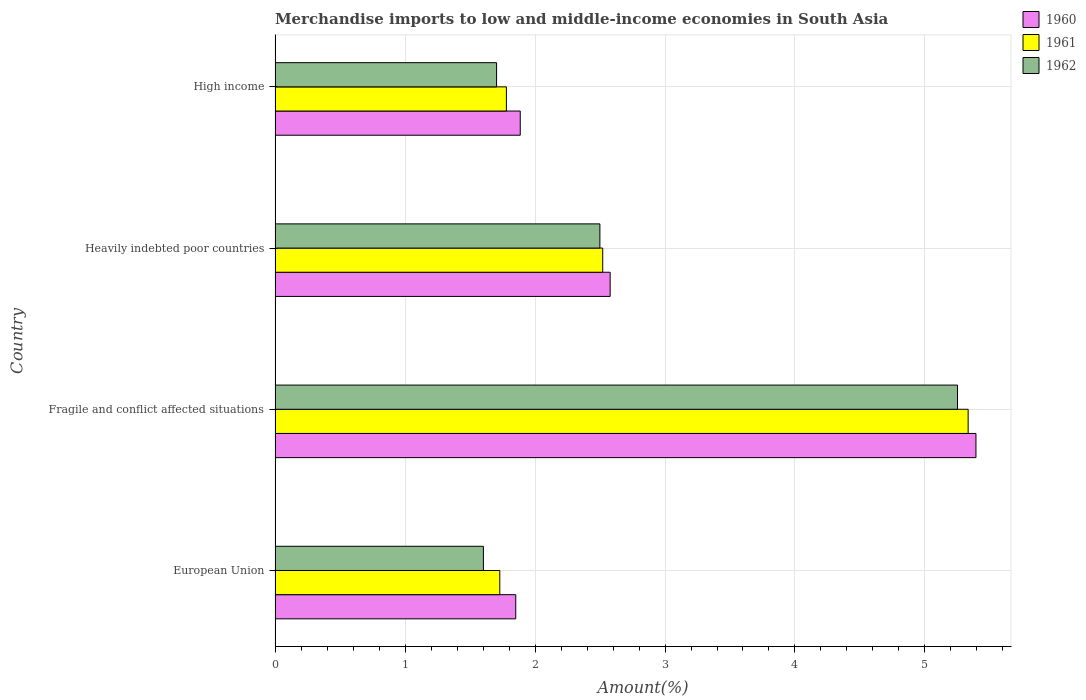How many groups of bars are there?
Offer a very short reply. 4. Are the number of bars per tick equal to the number of legend labels?
Make the answer very short. Yes. How many bars are there on the 3rd tick from the top?
Give a very brief answer. 3. How many bars are there on the 2nd tick from the bottom?
Your answer should be compact. 3. What is the label of the 4th group of bars from the top?
Make the answer very short. European Union. What is the percentage of amount earned from merchandise imports in 1961 in Fragile and conflict affected situations?
Offer a terse response. 5.33. Across all countries, what is the maximum percentage of amount earned from merchandise imports in 1961?
Provide a succinct answer. 5.33. Across all countries, what is the minimum percentage of amount earned from merchandise imports in 1962?
Ensure brevity in your answer.  1.6. In which country was the percentage of amount earned from merchandise imports in 1960 maximum?
Provide a short and direct response. Fragile and conflict affected situations. What is the total percentage of amount earned from merchandise imports in 1961 in the graph?
Your answer should be very brief. 11.36. What is the difference between the percentage of amount earned from merchandise imports in 1960 in Fragile and conflict affected situations and that in High income?
Your answer should be very brief. 3.51. What is the difference between the percentage of amount earned from merchandise imports in 1961 in High income and the percentage of amount earned from merchandise imports in 1962 in Fragile and conflict affected situations?
Your answer should be compact. -3.47. What is the average percentage of amount earned from merchandise imports in 1962 per country?
Provide a succinct answer. 2.76. What is the difference between the percentage of amount earned from merchandise imports in 1962 and percentage of amount earned from merchandise imports in 1961 in High income?
Offer a terse response. -0.08. In how many countries, is the percentage of amount earned from merchandise imports in 1961 greater than 1.2 %?
Your answer should be compact. 4. What is the ratio of the percentage of amount earned from merchandise imports in 1961 in European Union to that in Fragile and conflict affected situations?
Your response must be concise. 0.32. Is the percentage of amount earned from merchandise imports in 1960 in European Union less than that in Heavily indebted poor countries?
Offer a terse response. Yes. What is the difference between the highest and the second highest percentage of amount earned from merchandise imports in 1960?
Ensure brevity in your answer.  2.81. What is the difference between the highest and the lowest percentage of amount earned from merchandise imports in 1961?
Provide a short and direct response. 3.6. Is it the case that in every country, the sum of the percentage of amount earned from merchandise imports in 1960 and percentage of amount earned from merchandise imports in 1961 is greater than the percentage of amount earned from merchandise imports in 1962?
Ensure brevity in your answer.  Yes. How many bars are there?
Provide a succinct answer. 12. What is the difference between two consecutive major ticks on the X-axis?
Your response must be concise. 1. Are the values on the major ticks of X-axis written in scientific E-notation?
Keep it short and to the point. No. How many legend labels are there?
Ensure brevity in your answer.  3. How are the legend labels stacked?
Keep it short and to the point. Vertical. What is the title of the graph?
Keep it short and to the point. Merchandise imports to low and middle-income economies in South Asia. What is the label or title of the X-axis?
Provide a succinct answer. Amount(%). What is the label or title of the Y-axis?
Give a very brief answer. Country. What is the Amount(%) of 1960 in European Union?
Keep it short and to the point. 1.85. What is the Amount(%) of 1961 in European Union?
Your response must be concise. 1.73. What is the Amount(%) of 1962 in European Union?
Make the answer very short. 1.6. What is the Amount(%) of 1960 in Fragile and conflict affected situations?
Offer a terse response. 5.39. What is the Amount(%) of 1961 in Fragile and conflict affected situations?
Make the answer very short. 5.33. What is the Amount(%) of 1962 in Fragile and conflict affected situations?
Make the answer very short. 5.25. What is the Amount(%) in 1960 in Heavily indebted poor countries?
Your response must be concise. 2.58. What is the Amount(%) of 1961 in Heavily indebted poor countries?
Make the answer very short. 2.52. What is the Amount(%) of 1962 in Heavily indebted poor countries?
Keep it short and to the point. 2.5. What is the Amount(%) in 1960 in High income?
Your response must be concise. 1.89. What is the Amount(%) in 1961 in High income?
Ensure brevity in your answer.  1.78. What is the Amount(%) in 1962 in High income?
Keep it short and to the point. 1.7. Across all countries, what is the maximum Amount(%) of 1960?
Keep it short and to the point. 5.39. Across all countries, what is the maximum Amount(%) in 1961?
Your answer should be very brief. 5.33. Across all countries, what is the maximum Amount(%) in 1962?
Ensure brevity in your answer.  5.25. Across all countries, what is the minimum Amount(%) of 1960?
Offer a terse response. 1.85. Across all countries, what is the minimum Amount(%) of 1961?
Your response must be concise. 1.73. Across all countries, what is the minimum Amount(%) in 1962?
Your response must be concise. 1.6. What is the total Amount(%) in 1960 in the graph?
Provide a succinct answer. 11.71. What is the total Amount(%) in 1961 in the graph?
Provide a succinct answer. 11.36. What is the total Amount(%) of 1962 in the graph?
Offer a very short reply. 11.06. What is the difference between the Amount(%) in 1960 in European Union and that in Fragile and conflict affected situations?
Give a very brief answer. -3.54. What is the difference between the Amount(%) in 1961 in European Union and that in Fragile and conflict affected situations?
Keep it short and to the point. -3.6. What is the difference between the Amount(%) in 1962 in European Union and that in Fragile and conflict affected situations?
Your response must be concise. -3.65. What is the difference between the Amount(%) of 1960 in European Union and that in Heavily indebted poor countries?
Make the answer very short. -0.73. What is the difference between the Amount(%) of 1961 in European Union and that in Heavily indebted poor countries?
Keep it short and to the point. -0.79. What is the difference between the Amount(%) of 1962 in European Union and that in Heavily indebted poor countries?
Ensure brevity in your answer.  -0.9. What is the difference between the Amount(%) of 1960 in European Union and that in High income?
Provide a succinct answer. -0.03. What is the difference between the Amount(%) in 1961 in European Union and that in High income?
Keep it short and to the point. -0.05. What is the difference between the Amount(%) of 1962 in European Union and that in High income?
Your response must be concise. -0.1. What is the difference between the Amount(%) of 1960 in Fragile and conflict affected situations and that in Heavily indebted poor countries?
Make the answer very short. 2.81. What is the difference between the Amount(%) in 1961 in Fragile and conflict affected situations and that in Heavily indebted poor countries?
Keep it short and to the point. 2.81. What is the difference between the Amount(%) in 1962 in Fragile and conflict affected situations and that in Heavily indebted poor countries?
Provide a short and direct response. 2.75. What is the difference between the Amount(%) of 1960 in Fragile and conflict affected situations and that in High income?
Ensure brevity in your answer.  3.51. What is the difference between the Amount(%) of 1961 in Fragile and conflict affected situations and that in High income?
Provide a succinct answer. 3.55. What is the difference between the Amount(%) of 1962 in Fragile and conflict affected situations and that in High income?
Your answer should be compact. 3.55. What is the difference between the Amount(%) in 1960 in Heavily indebted poor countries and that in High income?
Keep it short and to the point. 0.69. What is the difference between the Amount(%) of 1961 in Heavily indebted poor countries and that in High income?
Make the answer very short. 0.74. What is the difference between the Amount(%) of 1962 in Heavily indebted poor countries and that in High income?
Offer a terse response. 0.79. What is the difference between the Amount(%) of 1960 in European Union and the Amount(%) of 1961 in Fragile and conflict affected situations?
Ensure brevity in your answer.  -3.48. What is the difference between the Amount(%) of 1960 in European Union and the Amount(%) of 1962 in Fragile and conflict affected situations?
Offer a very short reply. -3.4. What is the difference between the Amount(%) in 1961 in European Union and the Amount(%) in 1962 in Fragile and conflict affected situations?
Your answer should be very brief. -3.52. What is the difference between the Amount(%) in 1960 in European Union and the Amount(%) in 1961 in Heavily indebted poor countries?
Make the answer very short. -0.67. What is the difference between the Amount(%) of 1960 in European Union and the Amount(%) of 1962 in Heavily indebted poor countries?
Provide a succinct answer. -0.65. What is the difference between the Amount(%) of 1961 in European Union and the Amount(%) of 1962 in Heavily indebted poor countries?
Offer a terse response. -0.77. What is the difference between the Amount(%) in 1960 in European Union and the Amount(%) in 1961 in High income?
Provide a succinct answer. 0.07. What is the difference between the Amount(%) of 1960 in European Union and the Amount(%) of 1962 in High income?
Keep it short and to the point. 0.15. What is the difference between the Amount(%) in 1961 in European Union and the Amount(%) in 1962 in High income?
Provide a succinct answer. 0.02. What is the difference between the Amount(%) in 1960 in Fragile and conflict affected situations and the Amount(%) in 1961 in Heavily indebted poor countries?
Provide a succinct answer. 2.87. What is the difference between the Amount(%) of 1960 in Fragile and conflict affected situations and the Amount(%) of 1962 in Heavily indebted poor countries?
Ensure brevity in your answer.  2.89. What is the difference between the Amount(%) of 1961 in Fragile and conflict affected situations and the Amount(%) of 1962 in Heavily indebted poor countries?
Ensure brevity in your answer.  2.83. What is the difference between the Amount(%) in 1960 in Fragile and conflict affected situations and the Amount(%) in 1961 in High income?
Provide a short and direct response. 3.61. What is the difference between the Amount(%) in 1960 in Fragile and conflict affected situations and the Amount(%) in 1962 in High income?
Your answer should be compact. 3.69. What is the difference between the Amount(%) of 1961 in Fragile and conflict affected situations and the Amount(%) of 1962 in High income?
Provide a succinct answer. 3.63. What is the difference between the Amount(%) of 1960 in Heavily indebted poor countries and the Amount(%) of 1961 in High income?
Provide a succinct answer. 0.8. What is the difference between the Amount(%) in 1960 in Heavily indebted poor countries and the Amount(%) in 1962 in High income?
Offer a terse response. 0.87. What is the difference between the Amount(%) of 1961 in Heavily indebted poor countries and the Amount(%) of 1962 in High income?
Provide a short and direct response. 0.82. What is the average Amount(%) in 1960 per country?
Make the answer very short. 2.93. What is the average Amount(%) of 1961 per country?
Give a very brief answer. 2.84. What is the average Amount(%) in 1962 per country?
Offer a terse response. 2.76. What is the difference between the Amount(%) in 1960 and Amount(%) in 1961 in European Union?
Your response must be concise. 0.12. What is the difference between the Amount(%) of 1960 and Amount(%) of 1962 in European Union?
Give a very brief answer. 0.25. What is the difference between the Amount(%) of 1961 and Amount(%) of 1962 in European Union?
Give a very brief answer. 0.13. What is the difference between the Amount(%) in 1960 and Amount(%) in 1961 in Fragile and conflict affected situations?
Ensure brevity in your answer.  0.06. What is the difference between the Amount(%) in 1960 and Amount(%) in 1962 in Fragile and conflict affected situations?
Ensure brevity in your answer.  0.14. What is the difference between the Amount(%) in 1961 and Amount(%) in 1962 in Fragile and conflict affected situations?
Keep it short and to the point. 0.08. What is the difference between the Amount(%) in 1960 and Amount(%) in 1961 in Heavily indebted poor countries?
Provide a succinct answer. 0.06. What is the difference between the Amount(%) in 1960 and Amount(%) in 1962 in Heavily indebted poor countries?
Provide a succinct answer. 0.08. What is the difference between the Amount(%) of 1961 and Amount(%) of 1962 in Heavily indebted poor countries?
Your response must be concise. 0.02. What is the difference between the Amount(%) in 1960 and Amount(%) in 1961 in High income?
Your answer should be compact. 0.11. What is the difference between the Amount(%) in 1960 and Amount(%) in 1962 in High income?
Your answer should be compact. 0.18. What is the difference between the Amount(%) in 1961 and Amount(%) in 1962 in High income?
Make the answer very short. 0.08. What is the ratio of the Amount(%) in 1960 in European Union to that in Fragile and conflict affected situations?
Provide a succinct answer. 0.34. What is the ratio of the Amount(%) in 1961 in European Union to that in Fragile and conflict affected situations?
Offer a terse response. 0.32. What is the ratio of the Amount(%) of 1962 in European Union to that in Fragile and conflict affected situations?
Offer a terse response. 0.31. What is the ratio of the Amount(%) in 1960 in European Union to that in Heavily indebted poor countries?
Your answer should be very brief. 0.72. What is the ratio of the Amount(%) in 1961 in European Union to that in Heavily indebted poor countries?
Give a very brief answer. 0.69. What is the ratio of the Amount(%) of 1962 in European Union to that in Heavily indebted poor countries?
Ensure brevity in your answer.  0.64. What is the ratio of the Amount(%) of 1960 in European Union to that in High income?
Make the answer very short. 0.98. What is the ratio of the Amount(%) in 1961 in European Union to that in High income?
Give a very brief answer. 0.97. What is the ratio of the Amount(%) of 1962 in European Union to that in High income?
Your answer should be very brief. 0.94. What is the ratio of the Amount(%) in 1960 in Fragile and conflict affected situations to that in Heavily indebted poor countries?
Provide a succinct answer. 2.09. What is the ratio of the Amount(%) in 1961 in Fragile and conflict affected situations to that in Heavily indebted poor countries?
Your answer should be compact. 2.12. What is the ratio of the Amount(%) of 1962 in Fragile and conflict affected situations to that in Heavily indebted poor countries?
Offer a very short reply. 2.1. What is the ratio of the Amount(%) in 1960 in Fragile and conflict affected situations to that in High income?
Offer a terse response. 2.86. What is the ratio of the Amount(%) in 1961 in Fragile and conflict affected situations to that in High income?
Offer a terse response. 3. What is the ratio of the Amount(%) of 1962 in Fragile and conflict affected situations to that in High income?
Offer a terse response. 3.08. What is the ratio of the Amount(%) of 1960 in Heavily indebted poor countries to that in High income?
Provide a succinct answer. 1.37. What is the ratio of the Amount(%) of 1961 in Heavily indebted poor countries to that in High income?
Offer a very short reply. 1.42. What is the ratio of the Amount(%) in 1962 in Heavily indebted poor countries to that in High income?
Give a very brief answer. 1.47. What is the difference between the highest and the second highest Amount(%) in 1960?
Provide a succinct answer. 2.81. What is the difference between the highest and the second highest Amount(%) in 1961?
Provide a short and direct response. 2.81. What is the difference between the highest and the second highest Amount(%) in 1962?
Your answer should be compact. 2.75. What is the difference between the highest and the lowest Amount(%) of 1960?
Offer a very short reply. 3.54. What is the difference between the highest and the lowest Amount(%) in 1961?
Offer a very short reply. 3.6. What is the difference between the highest and the lowest Amount(%) of 1962?
Give a very brief answer. 3.65. 